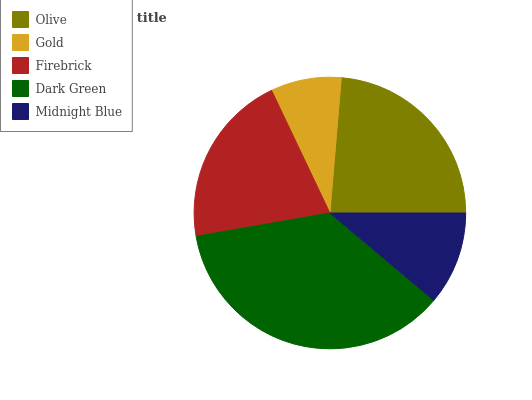Is Gold the minimum?
Answer yes or no. Yes. Is Dark Green the maximum?
Answer yes or no. Yes. Is Firebrick the minimum?
Answer yes or no. No. Is Firebrick the maximum?
Answer yes or no. No. Is Firebrick greater than Gold?
Answer yes or no. Yes. Is Gold less than Firebrick?
Answer yes or no. Yes. Is Gold greater than Firebrick?
Answer yes or no. No. Is Firebrick less than Gold?
Answer yes or no. No. Is Firebrick the high median?
Answer yes or no. Yes. Is Firebrick the low median?
Answer yes or no. Yes. Is Olive the high median?
Answer yes or no. No. Is Olive the low median?
Answer yes or no. No. 